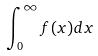<formula> <loc_0><loc_0><loc_500><loc_500>\int _ { 0 } ^ { \infty } f ( x ) d x</formula> 